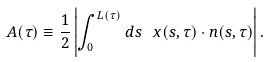<formula> <loc_0><loc_0><loc_500><loc_500>A ( \tau ) \equiv \frac { 1 } { 2 } \left | \int _ { 0 } ^ { L ( \tau ) } d s \, \ x ( s , \tau ) \cdot n ( s , \tau ) \right | .</formula> 